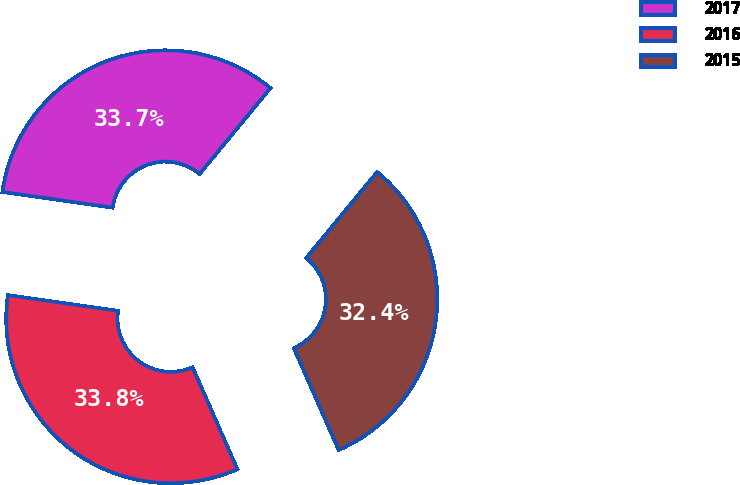Convert chart to OTSL. <chart><loc_0><loc_0><loc_500><loc_500><pie_chart><fcel>2017<fcel>2016<fcel>2015<nl><fcel>33.72%<fcel>33.85%<fcel>32.43%<nl></chart> 